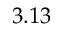Convert formula to latex. <formula><loc_0><loc_0><loc_500><loc_500>3 . 1 3</formula> 